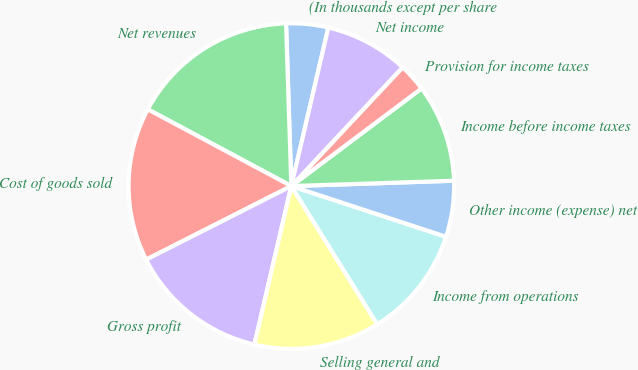Convert chart to OTSL. <chart><loc_0><loc_0><loc_500><loc_500><pie_chart><fcel>(In thousands except per share<fcel>Net revenues<fcel>Cost of goods sold<fcel>Gross profit<fcel>Selling general and<fcel>Income from operations<fcel>Other income (expense) net<fcel>Income before income taxes<fcel>Provision for income taxes<fcel>Net income<nl><fcel>4.17%<fcel>16.67%<fcel>15.28%<fcel>13.89%<fcel>12.5%<fcel>11.11%<fcel>5.56%<fcel>9.72%<fcel>2.78%<fcel>8.33%<nl></chart> 